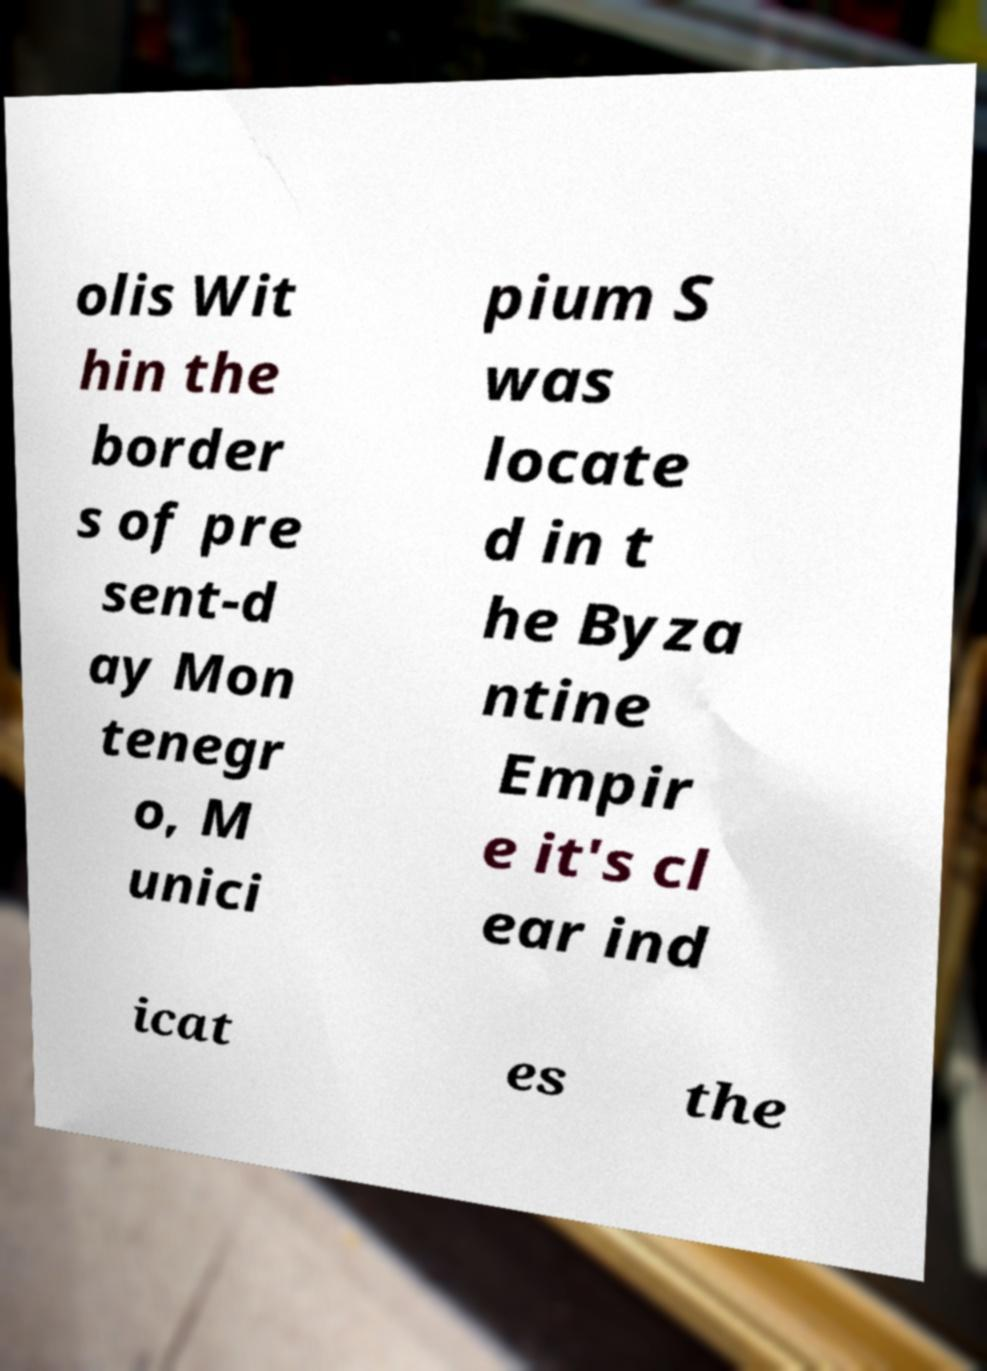Please identify and transcribe the text found in this image. olis Wit hin the border s of pre sent-d ay Mon tenegr o, M unici pium S was locate d in t he Byza ntine Empir e it's cl ear ind icat es the 